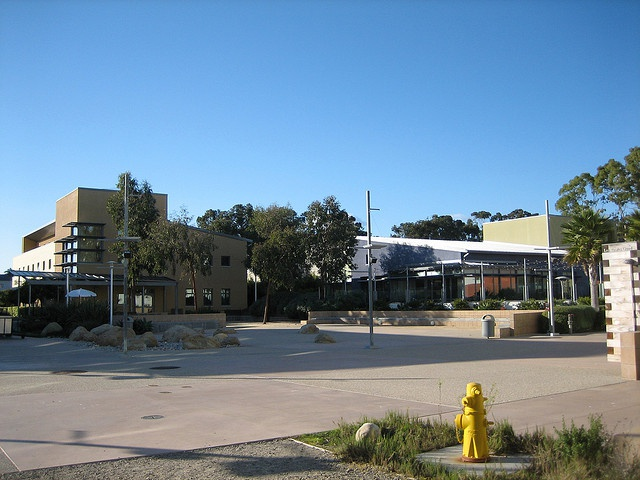Describe the objects in this image and their specific colors. I can see a fire hydrant in gray, olive, and gold tones in this image. 